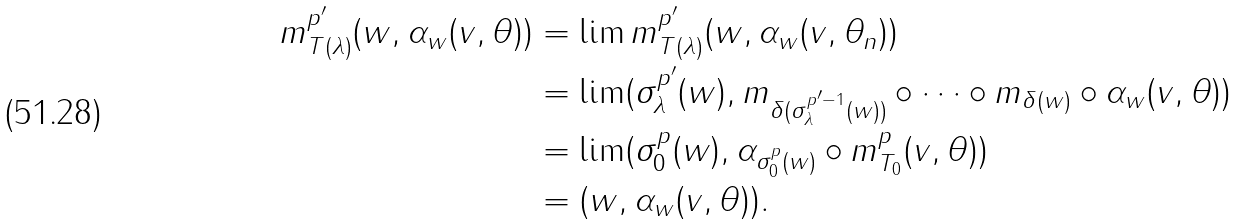Convert formula to latex. <formula><loc_0><loc_0><loc_500><loc_500>m _ { T ( \lambda ) } ^ { p ^ { \prime } } ( w , \alpha _ { w } ( v , \theta ) ) & = \lim m _ { T ( \lambda ) } ^ { p ^ { \prime } } ( w , \alpha _ { w } ( v , \theta _ { n } ) ) \\ & = \lim ( \sigma _ { \lambda } ^ { p ^ { \prime } } ( w ) , m _ { \delta ( \sigma _ { \lambda } ^ { p ^ { \prime } - 1 } ( w ) ) } \circ \cdots \circ m _ { \delta ( w ) } \circ \alpha _ { w } ( v , \theta ) ) \\ & = \lim ( \sigma _ { 0 } ^ { p } ( w ) , \alpha _ { \sigma _ { 0 } ^ { p } ( w ) } \circ m _ { T _ { 0 } } ^ { p } ( v , \theta ) ) \\ & = ( w , \alpha _ { w } ( v , \theta ) ) .</formula> 